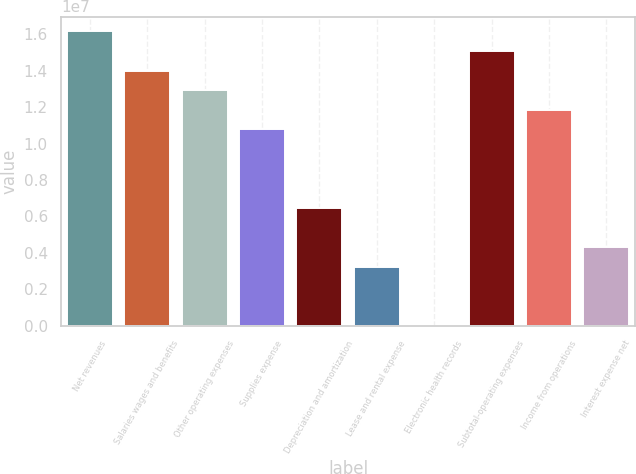Convert chart. <chart><loc_0><loc_0><loc_500><loc_500><bar_chart><fcel>Net revenues<fcel>Salaries wages and benefits<fcel>Other operating expenses<fcel>Supplies expense<fcel>Depreciation and amortization<fcel>Lease and rental expense<fcel>Electronic health records<fcel>Subtotal-operating expenses<fcel>Income from operations<fcel>Interest expense net<nl><fcel>1.61584e+07<fcel>1.4004e+07<fcel>1.29267e+07<fcel>1.07723e+07<fcel>6.46337e+06<fcel>3.23169e+06<fcel>2.59<fcel>1.50812e+07<fcel>1.18495e+07<fcel>4.30891e+06<nl></chart> 